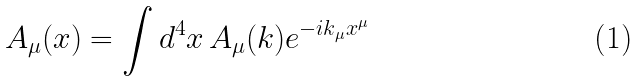Convert formula to latex. <formula><loc_0><loc_0><loc_500><loc_500>A _ { \mu } ( x ) = \int d ^ { 4 } x \, A _ { \mu } ( k ) e ^ { - i k _ { \mu } x ^ { \mu } }</formula> 